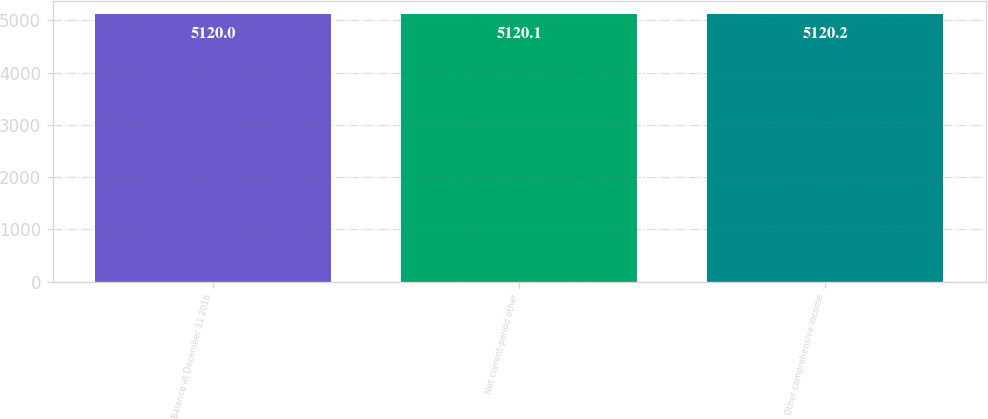Convert chart to OTSL. <chart><loc_0><loc_0><loc_500><loc_500><bar_chart><fcel>Balance at December 31 2016<fcel>Net current-period other<fcel>Other comprehensive income<nl><fcel>5120<fcel>5120.1<fcel>5120.2<nl></chart> 